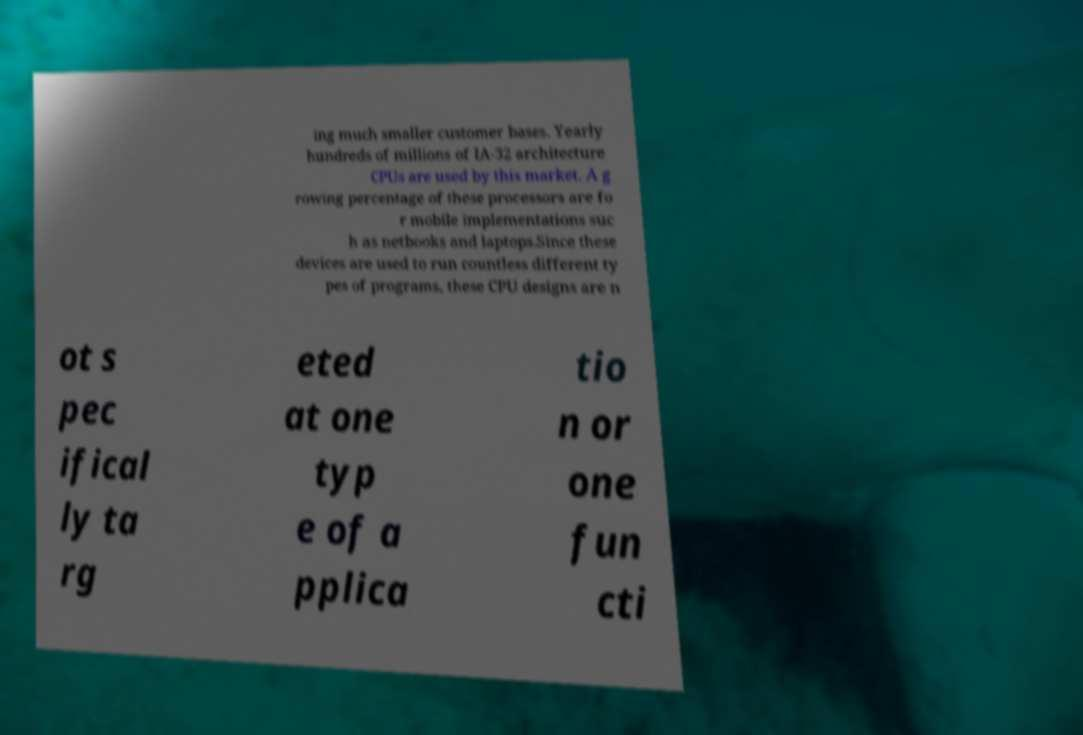Could you assist in decoding the text presented in this image and type it out clearly? ing much smaller customer bases. Yearly hundreds of millions of IA-32 architecture CPUs are used by this market. A g rowing percentage of these processors are fo r mobile implementations suc h as netbooks and laptops.Since these devices are used to run countless different ty pes of programs, these CPU designs are n ot s pec ifical ly ta rg eted at one typ e of a pplica tio n or one fun cti 